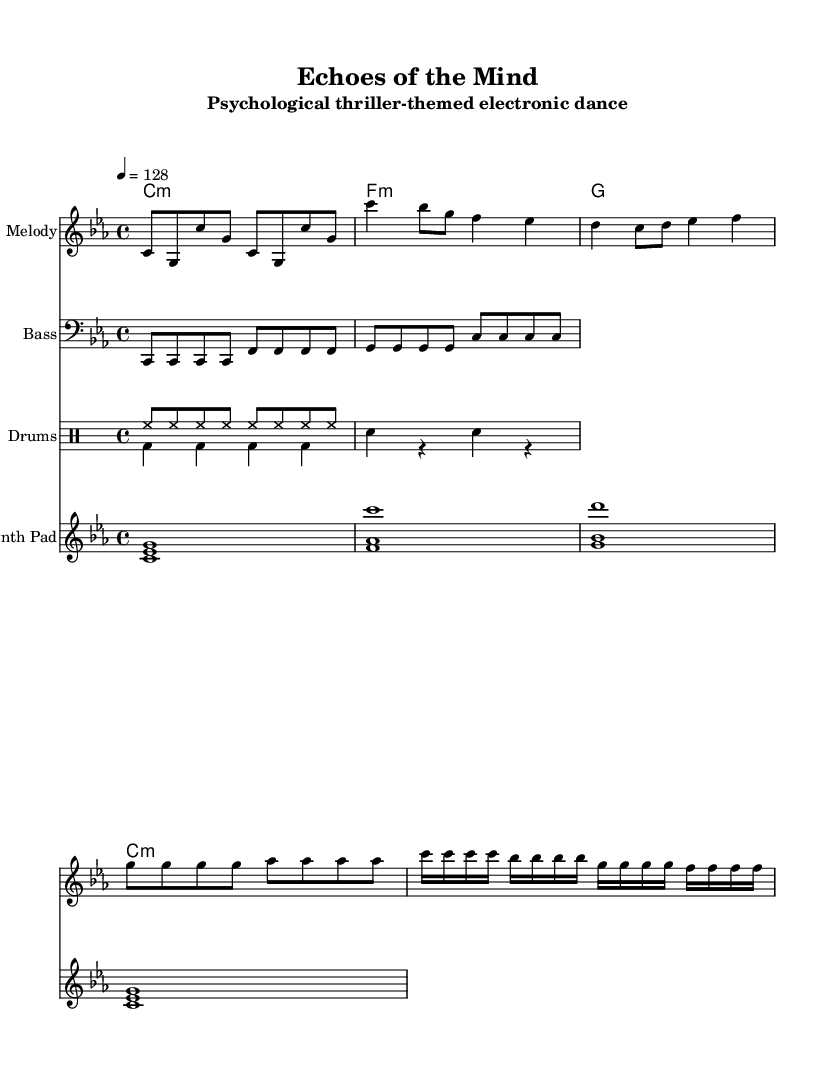What is the key signature of this music? The key signature is C minor, which consists of three flats: B flat, E flat, and A flat. This can be found at the beginning of the music sheet.
Answer: C minor What is the time signature of this piece? The time signature is 4/4, meaning there are four beats per measure and a quarter note gets one beat. This is indicated at the beginning of the score.
Answer: 4/4 What is the tempo marking for this dance track? The tempo marking specifies a tempo of 128 beats per minute, indicated by the tempo notation at the start of the piece.
Answer: 128 How many parts are there in the score? There are five distinct parts visible in the score: Melody, Bass, Drums (with two voices), and Synth Pad. Each part is represented separately in the score layout.
Answer: Five What type of electronic instrument is featured prominently in this dance track? A Synth Pad is featured prominently in this piece, as evidenced by its dedicated staff in the score, contributing to the atmospheric sound typical of electronic dance tracks.
Answer: Synth Pad During which section does the musical "drop" occur? The "drop" occurs after the build-up section, marked by a significant change in dynamics and rhythmic density. In this sheet, it follows the buildup motif and is characterized by rapid note repetitions.
Answer: Drop What is the rhythmic pattern of the drums in the downbeat section? The downbeat section features a pattern of bass drum followed by snare and rests, characterized by a consistent alternating rhythm visible in the drum staff. This indicates a structured foundation that propels the track forward.
Answer: Alternating bass and snare 